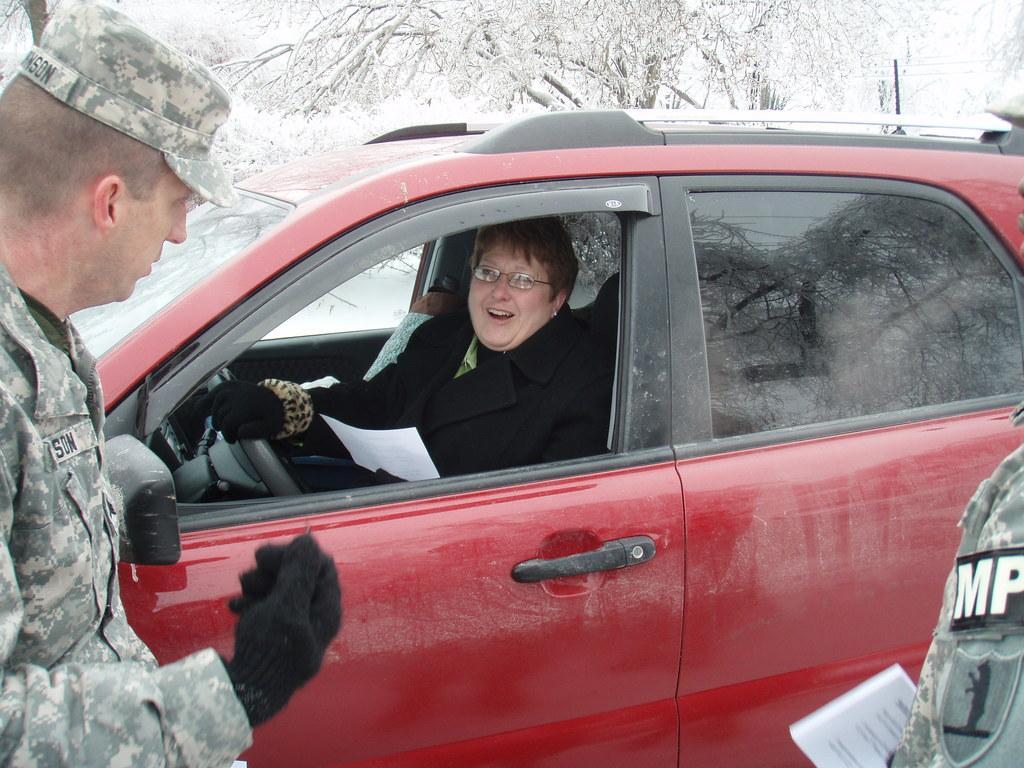Please provide a concise description of this image. In this picture there are two people standing and there is a person sitting inside a car and holding a paper. In the background of the image we can see trees covered with snow. 